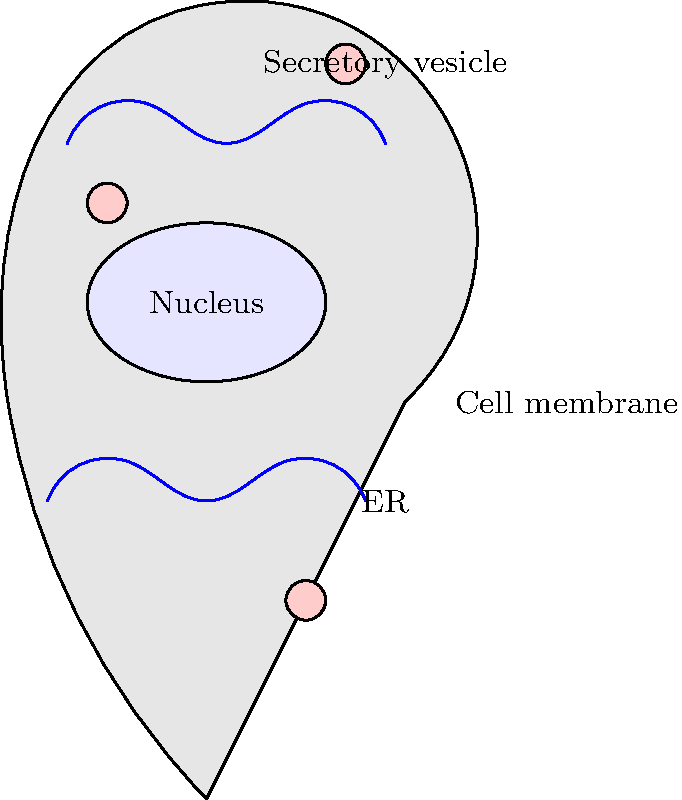Analyze the cross-section diagram of a thymic epithelial cell. Which structural feature is most crucial for its role in T cell development, and why? To answer this question, let's analyze the key structures of the thymic epithelial cell and their roles in T cell development:

1. Nucleus: Contains genetic material but doesn't directly interact with developing T cells.

2. Endoplasmic Reticulum (ER): 
   - Visible as blue wavy lines in the diagram.
   - Crucial for protein synthesis, including MHC molecules and thymic hormones.

3. Secretory vesicles:
   - Shown as small pink circles.
   - Transport proteins from ER to cell membrane or extracellular space.

4. Cell membrane:
   - The outer boundary of the cell.
   - Presents MHC molecules and other proteins necessary for T cell selection.

The most crucial feature for T cell development is the extensive endoplasmic reticulum (ER). Here's why:

1. MHC molecule production: The ER is the site where MHC class I and II molecules are synthesized and loaded with peptides. These MHC-peptide complexes are essential for positive and negative selection of T cells.

2. Thymic hormone production: The ER is involved in the synthesis of thymic hormones like thymulin, thymopoietin, and thymosin, which promote T cell maturation.

3. Protein trafficking: The ER works in conjunction with the secretory vesicles to ensure proper trafficking of MHC molecules and other proteins to the cell surface, where they can interact with developing T cells.

4. Calcium storage: The ER serves as a calcium store, which is important for signaling processes involved in T cell development.

While the cell membrane is the site of direct interaction with T cells, its ability to present the necessary molecules depends on the ER's protein synthesis and processing capabilities. Therefore, the extensive ER network is the most crucial structural feature for the thymic epithelial cell's role in T cell development.
Answer: Extensive endoplasmic reticulum (ER) for MHC molecule and thymic hormone production 